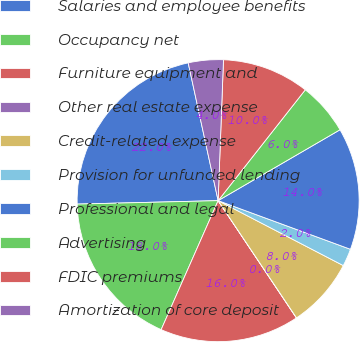Convert chart. <chart><loc_0><loc_0><loc_500><loc_500><pie_chart><fcel>Salaries and employee benefits<fcel>Occupancy net<fcel>Furniture equipment and<fcel>Other real estate expense<fcel>Credit-related expense<fcel>Provision for unfunded lending<fcel>Professional and legal<fcel>Advertising<fcel>FDIC premiums<fcel>Amortization of core deposit<nl><fcel>21.98%<fcel>17.99%<fcel>15.99%<fcel>0.01%<fcel>8.0%<fcel>2.01%<fcel>13.99%<fcel>6.01%<fcel>10.0%<fcel>4.01%<nl></chart> 